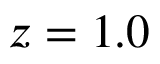<formula> <loc_0><loc_0><loc_500><loc_500>z = 1 . 0</formula> 